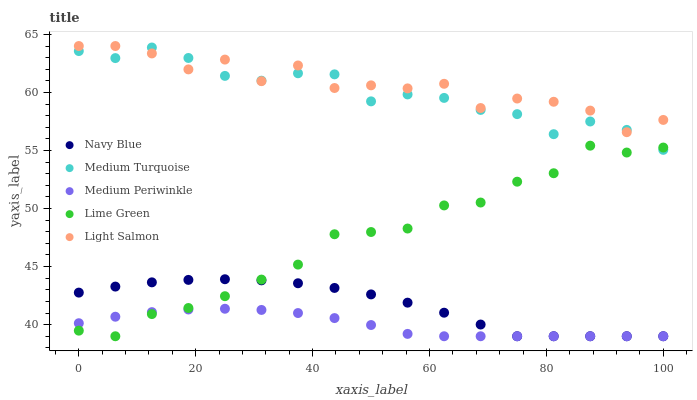Does Medium Periwinkle have the minimum area under the curve?
Answer yes or no. Yes. Does Light Salmon have the maximum area under the curve?
Answer yes or no. Yes. Does Navy Blue have the minimum area under the curve?
Answer yes or no. No. Does Navy Blue have the maximum area under the curve?
Answer yes or no. No. Is Medium Periwinkle the smoothest?
Answer yes or no. Yes. Is Light Salmon the roughest?
Answer yes or no. Yes. Is Navy Blue the smoothest?
Answer yes or no. No. Is Navy Blue the roughest?
Answer yes or no. No. Does Lime Green have the lowest value?
Answer yes or no. Yes. Does Light Salmon have the lowest value?
Answer yes or no. No. Does Light Salmon have the highest value?
Answer yes or no. Yes. Does Navy Blue have the highest value?
Answer yes or no. No. Is Navy Blue less than Light Salmon?
Answer yes or no. Yes. Is Light Salmon greater than Medium Periwinkle?
Answer yes or no. Yes. Does Navy Blue intersect Lime Green?
Answer yes or no. Yes. Is Navy Blue less than Lime Green?
Answer yes or no. No. Is Navy Blue greater than Lime Green?
Answer yes or no. No. Does Navy Blue intersect Light Salmon?
Answer yes or no. No. 